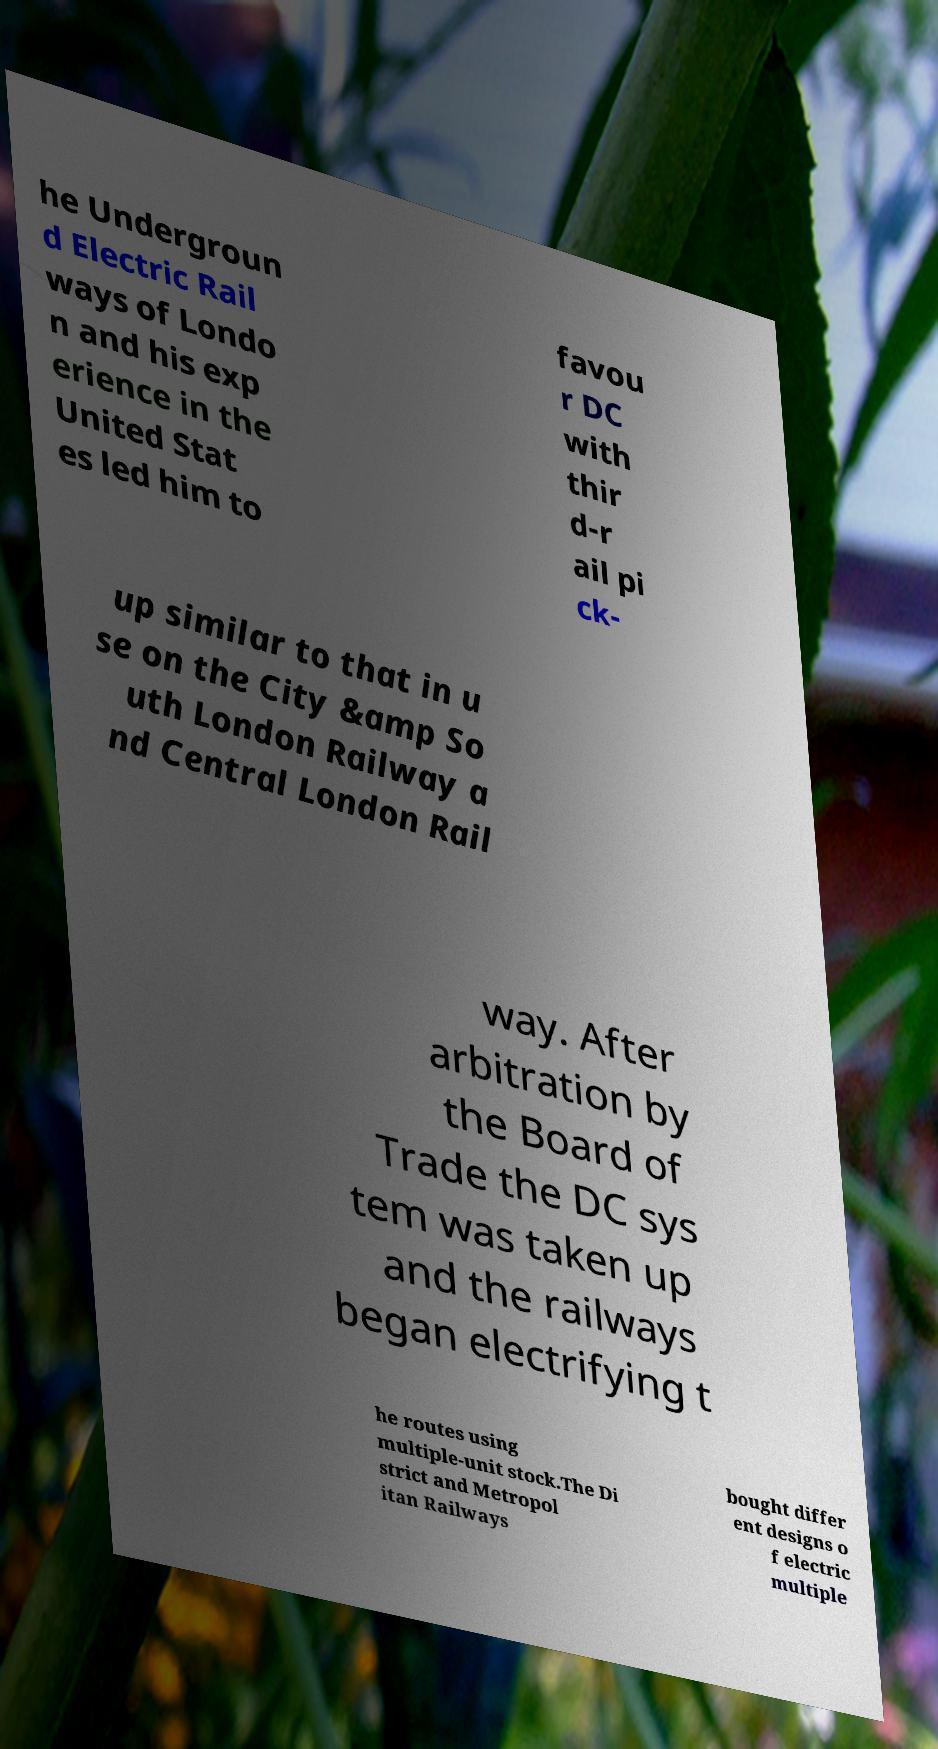I need the written content from this picture converted into text. Can you do that? he Undergroun d Electric Rail ways of Londo n and his exp erience in the United Stat es led him to favou r DC with thir d-r ail pi ck- up similar to that in u se on the City &amp So uth London Railway a nd Central London Rail way. After arbitration by the Board of Trade the DC sys tem was taken up and the railways began electrifying t he routes using multiple-unit stock.The Di strict and Metropol itan Railways bought differ ent designs o f electric multiple 